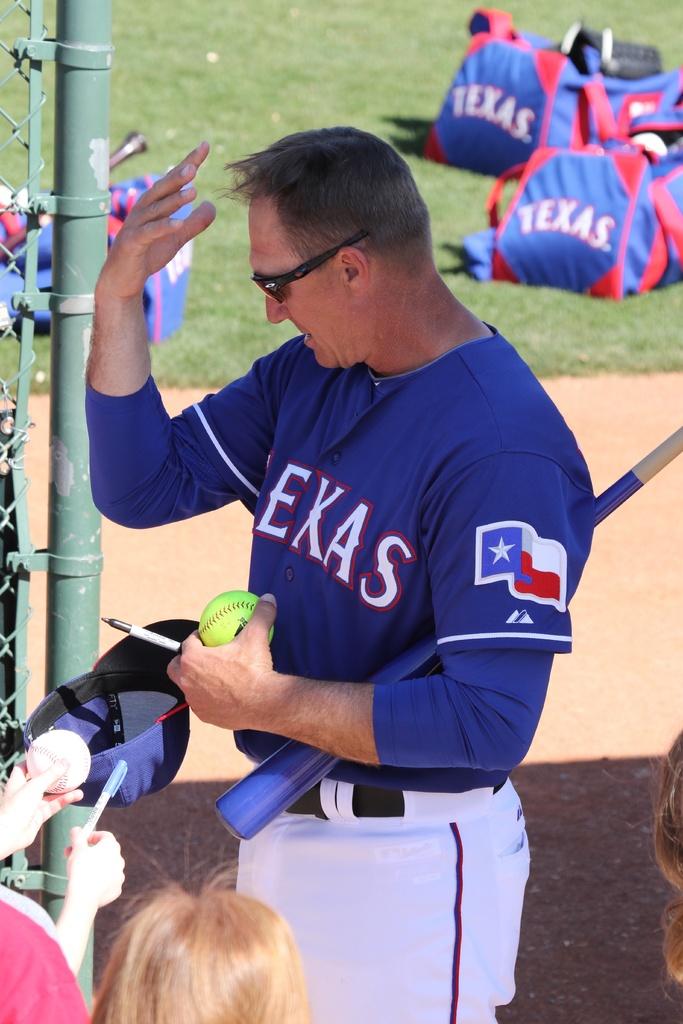What state is written on the bags in the background?
Provide a succinct answer. Texas. 